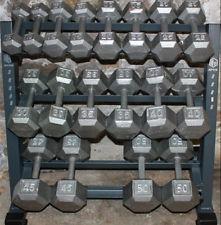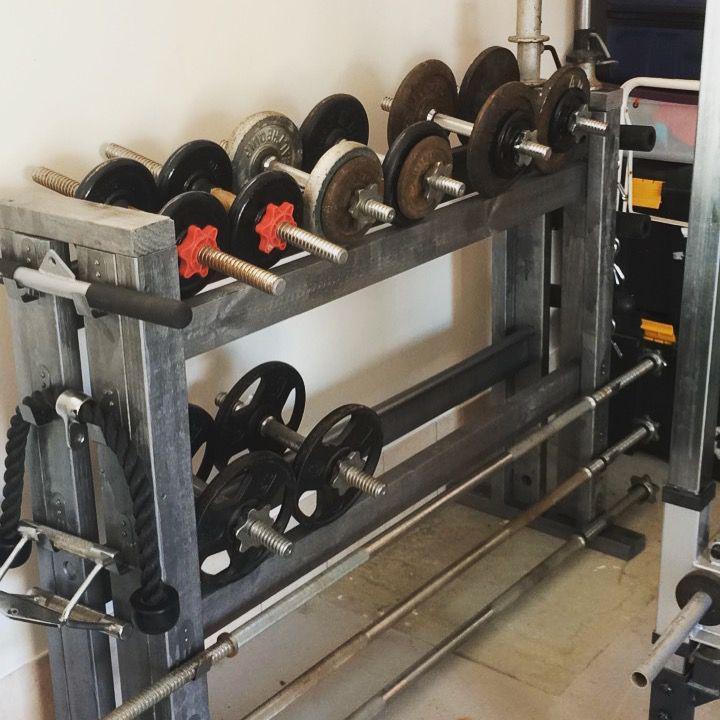The first image is the image on the left, the second image is the image on the right. Analyze the images presented: Is the assertion "At least some of the weights in one of the pictures have red on them." valid? Answer yes or no. Yes. The first image is the image on the left, the second image is the image on the right. For the images displayed, is the sentence "there is a weight racj with two rows of weights in the left image" factually correct? Answer yes or no. No. 